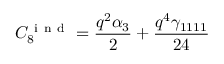Convert formula to latex. <formula><loc_0><loc_0><loc_500><loc_500>C _ { 8 } ^ { i n d } = \frac { q ^ { 2 } \alpha _ { 3 } } { 2 } + \frac { q ^ { 4 } \gamma _ { 1 1 1 1 } } { 2 4 }</formula> 